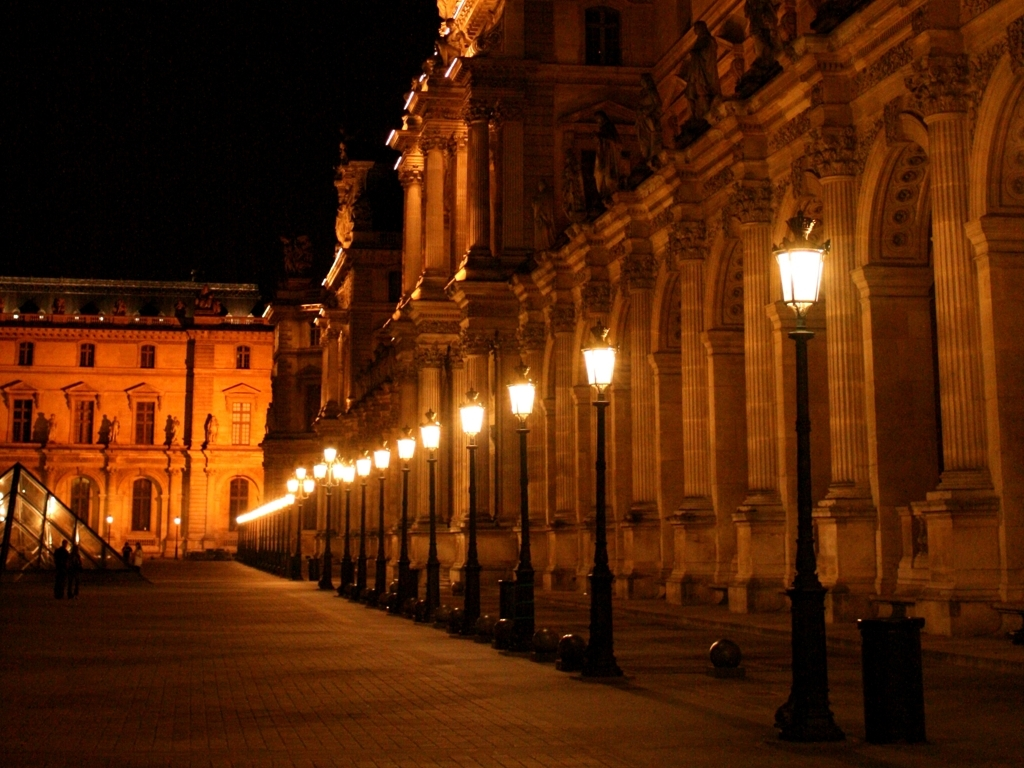Is the frame well-filled? Yes, the frame is well-filled. The perspective created by the line of street lamps underscores the depth of the scene, creating a visually appealing composition with warm lighting that complements the classical architecture. 